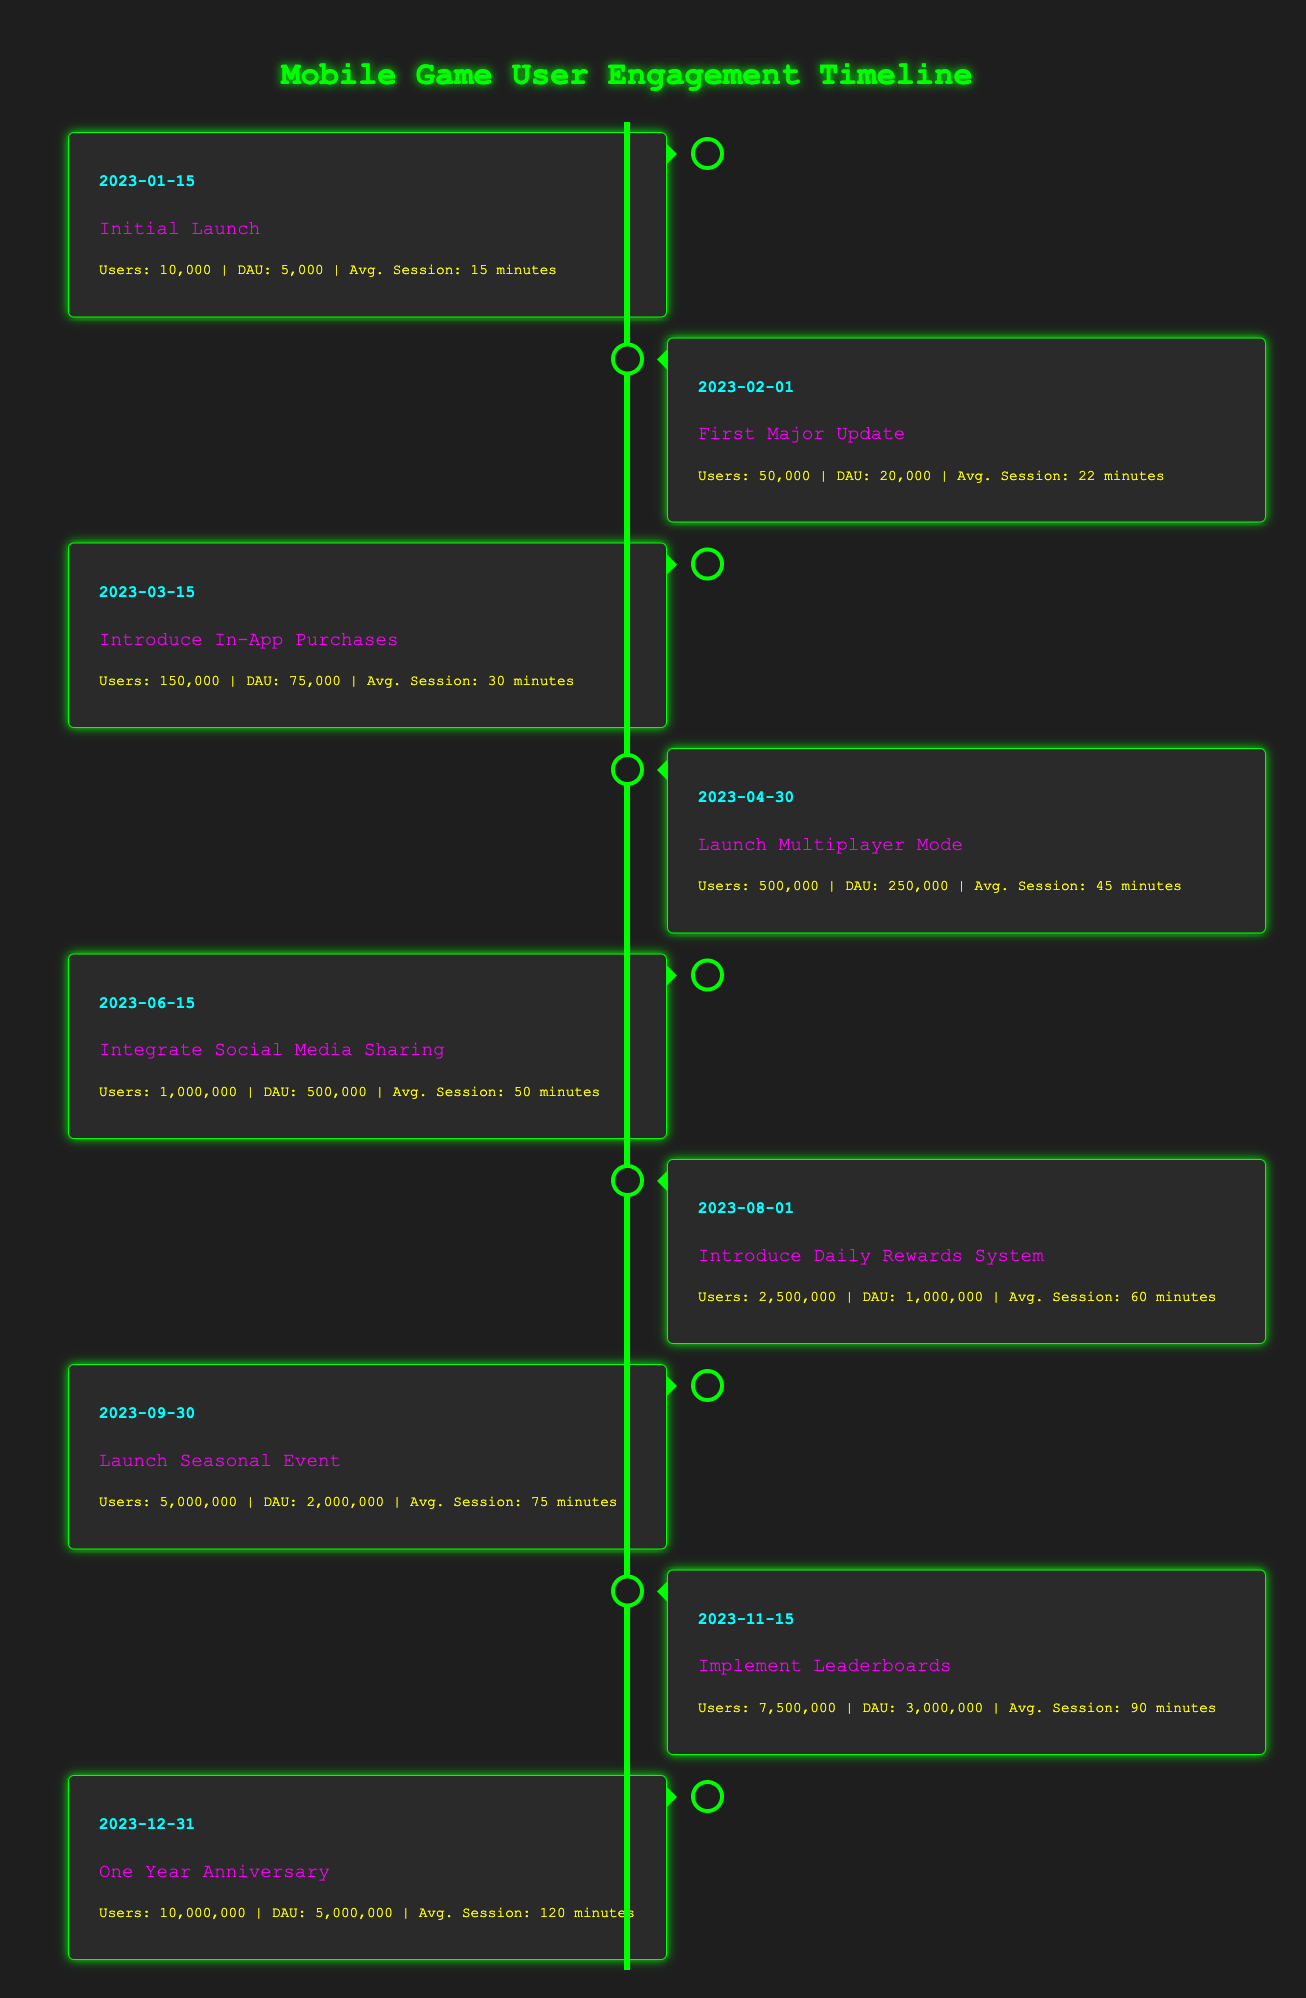What was the user count at the time of the Initial Launch? The user count at the Initial Launch, which was on January 15, 2023, is listed as 10,000 in the table.
Answer: 10,000 What is the average session time after the First Major Update? After the First Major Update on February 1, 2023, the average session time increased to 22 minutes, as indicated in the data.
Answer: 22 minutes How many daily active users did the game have when it launched the Multiplayer Mode? The Multiplayer Mode was launched on April 30, 2023, during which there were 250,000 daily active users, as shown in the table.
Answer: 250,000 What was the percentage increase in user count from the Launch Multiplayer Mode to Integrate Social Media Sharing? The user count at the Launch Multiplayer Mode was 500,000, and at Integrate Social Media Sharing, it was 1,000,000. The increase can be calculated as: (1,000,000 - 500,000) / 500,000 * 100 = 100%.
Answer: 100% Was there an increase in daily active users from August 1 to September 30 of 2023? The number of daily active users on August 1 was 1,000,000, and on September 30 it was 2,000,000, showing an increase. We confirm that 2,000,000 is greater than 1,000,000.
Answer: Yes How many milestones reached over the period had an average session time of over 60 minutes? Reviewing the milestones, from the data, we see that the average session times are over 60 minutes for three milestones: Introduce Daily Rewards System (60 minutes), Launch Seasonal Event (75 minutes), and Implement Leaderboards (90 minutes). Thus, there are three milestones.
Answer: 3 What is the total user count at the One Year Anniversary compared to the Initial Launch? The total user count at the One Year Anniversary (December 31, 2023) is 10,000,000 and at the Initial Launch (January 15, 2023) is 10,000. To find the difference: 10,000,000 - 10,000 = 9,990,000.
Answer: 9,990,000 Which milestone had the highest daily active users and what was that number? The milestone with the highest daily active users is the One Year Anniversary on December 31, 2023, with 5,000,000 daily active users, according to the table data.
Answer: 5,000,000 What was the average session time after the introduction of In-App Purchases? After introducing In-App Purchases on March 15, 2023, the average session time was 30 minutes, as provided in the table.
Answer: 30 minutes 